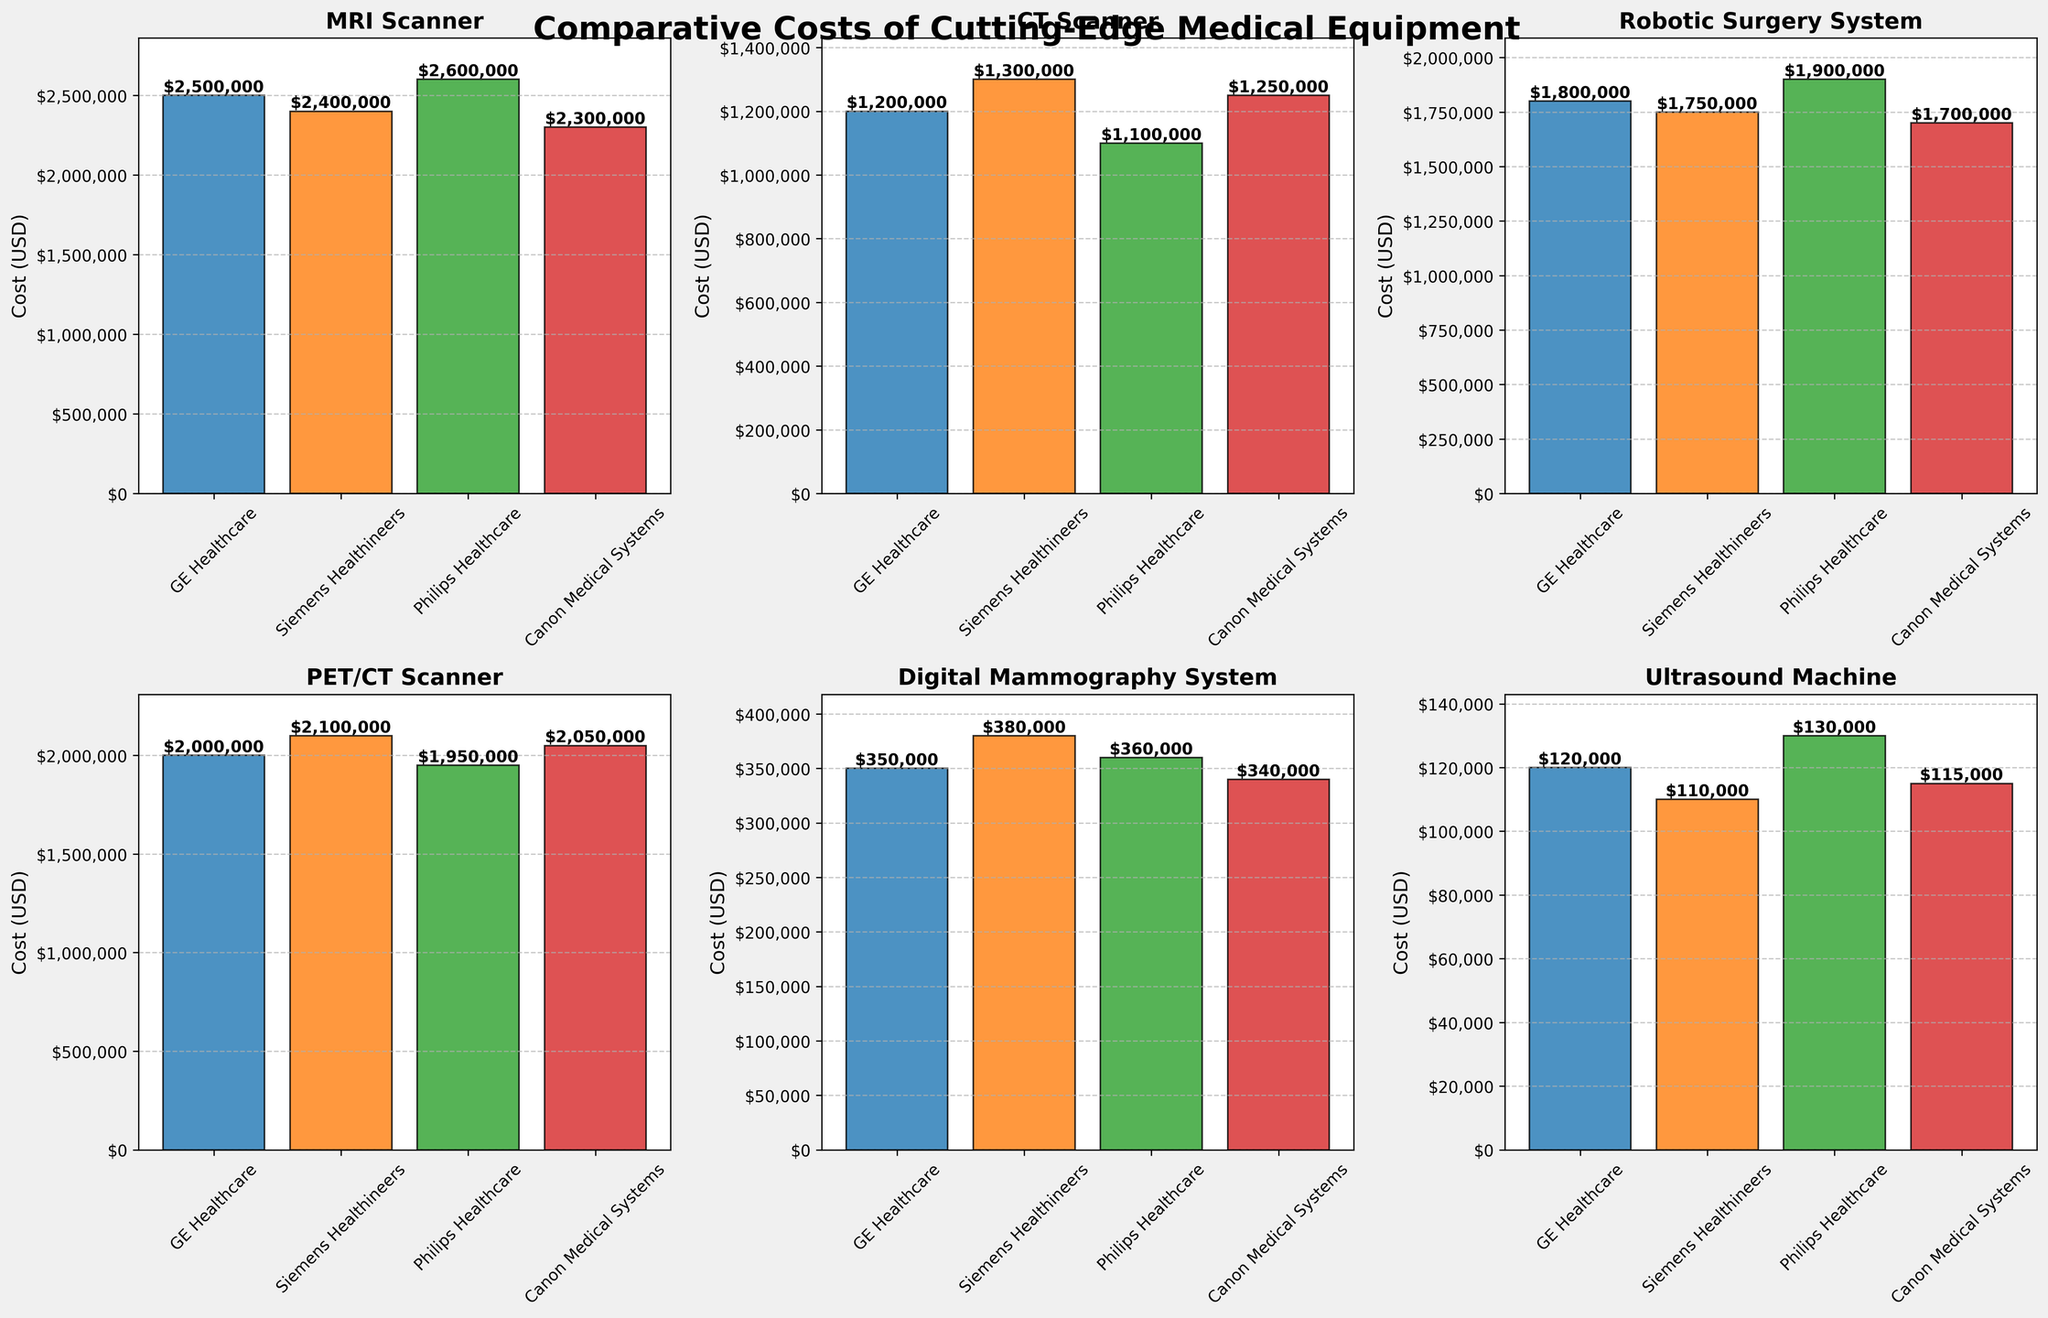What's the cost of the MRI Scanner from GE Healthcare? You can find the cost of the MRI Scanner from GE Healthcare by looking at the height of the bar labeled "GE Healthcare" in the MRI Scanner subplot. The value is also indicated on top of the bar.
Answer: $2,500,000 Which manufacturing company offers the least expensive CT Scanner? To identify the least expensive CT Scanner, compare the heights of the bars representing the costs from all manufacturers (GE Healthcare, Siemens Healthineers, Philips Healthcare, Canon Medical Systems) in the CT Scanner subplot. The shortest bar corresponds to Philips Healthcare.
Answer: Philips Healthcare By how much does the cost of the Robotic Surgery System from Philips Healthcare exceed the cost from Canon Medical Systems? First, find the cost of the Robotic Surgery System from Philips Healthcare ($1,900,000) and Canon Medical Systems ($1,700,000) by looking at the respective bars. Subtract the Canon Medical Systems cost from the Philips Healthcare cost: $1,900,000 - $1,700,000.
Answer: $200,000 What is the average cost of the Ultrasound Machine across all manufacturers? To calculate the average cost of the Ultrasound Machine, identify the costs from GE Healthcare ($120,000), Siemens Healthineers ($110,000), Philips Healthcare ($130,000), and Canon Medical Systems ($115,000). Sum these values and divide by 4: (120,000 + 110,000 + 130,000 + 115,000) / 4.
Answer: $118,750 Are there any pieces of equipment where Siemens Healthineers is the most expensive option? Check the Siemens Healthineers bars across all subplots and see if any of them are the tallest within their category. Siemens Healthineers is the most expensive for the Digital Mammography System.
Answer: Digital Mammography System How much more does a Digital Mammography System from Siemens Healthineers cost compared to GE Healthcare? Look at the Digital Mammography System costs for Siemens Healthineers ($380,000) and GE Healthcare ($350,000). Subtract the GE Healthcare cost from the Siemens Healthineers cost: $380,000 - $350,000.
Answer: $30,000 What is the cost for a PET/CT Scanner from Canon Medical Systems, and how does it compare to the cost from GE Healthcare? First, find the PET/CT Scanner costs for Canon Medical Systems ($2,050,000) and GE Healthcare ($2,000,000). Then calculate the difference: $2,050,000 - $2,000,000. Canon Medical Systems is slightly more expensive.
Answer: $50,000 more Which manufacturer consistently provides the least expensive options? Compare the bars for the least expensive options across all subplots. Check which manufacturer appears most frequently as the lowest cost supplier. Canon Medical Systems has the lowest costs for MRI Scanner, Robotic Surgery System, and Digital Mammography System, making it the most frequent least expensive option.
Answer: Canon Medical Systems By how much does the most expensive Ultrasound Machine (Philips Healthcare) exceed the average cost of the Ultrasound Machine? First, find the cost of the most expensive Ultrasound Machine from Philips Healthcare ($130,000). Then calculate the average cost of the Ultrasound Machine from all manufacturers, which is $118,750. Subtract the average cost from the most expensive one: $130,000 - $118,750.
Answer: $11,250 